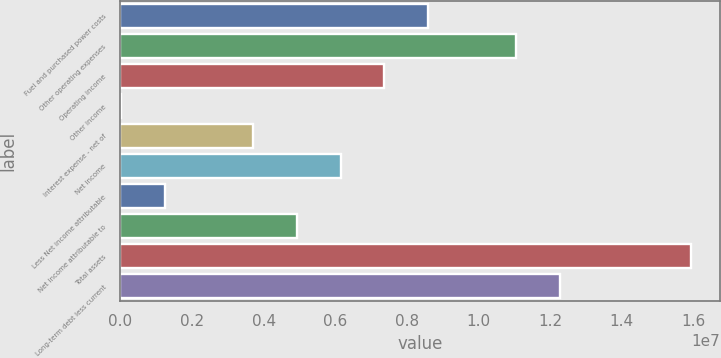Convert chart. <chart><loc_0><loc_0><loc_500><loc_500><bar_chart><fcel>Fuel and purchased power costs<fcel>Other operating expenses<fcel>Operating income<fcel>Other income<fcel>Interest expense - net of<fcel>Net income<fcel>Less Net income attributable<fcel>Net income attributable to<fcel>Total assets<fcel>Long-term debt less current<nl><fcel>8.59636e+06<fcel>1.10467e+07<fcel>7.37118e+06<fcel>20138<fcel>3.69566e+06<fcel>6.14601e+06<fcel>1.24531e+06<fcel>4.92083e+06<fcel>1.59474e+07<fcel>1.22719e+07<nl></chart> 